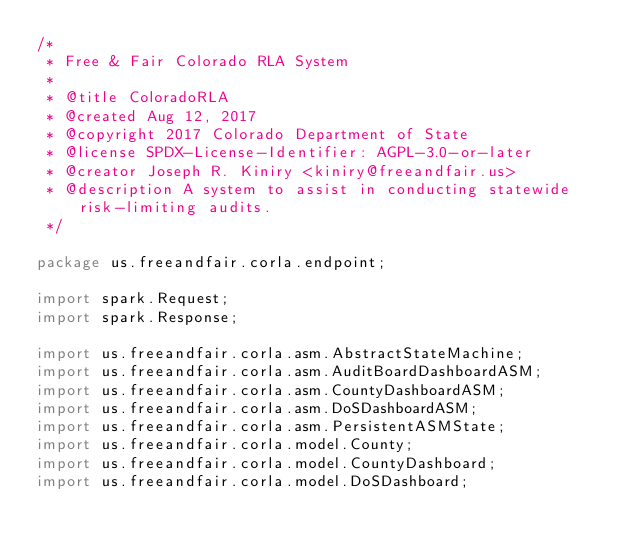<code> <loc_0><loc_0><loc_500><loc_500><_Java_>/*
 * Free & Fair Colorado RLA System
 * 
 * @title ColoradoRLA
 * @created Aug 12, 2017
 * @copyright 2017 Colorado Department of State
 * @license SPDX-License-Identifier: AGPL-3.0-or-later
 * @creator Joseph R. Kiniry <kiniry@freeandfair.us>
 * @description A system to assist in conducting statewide risk-limiting audits.
 */

package us.freeandfair.corla.endpoint;

import spark.Request;
import spark.Response;

import us.freeandfair.corla.asm.AbstractStateMachine;
import us.freeandfair.corla.asm.AuditBoardDashboardASM;
import us.freeandfair.corla.asm.CountyDashboardASM;
import us.freeandfair.corla.asm.DoSDashboardASM;
import us.freeandfair.corla.asm.PersistentASMState;
import us.freeandfair.corla.model.County;
import us.freeandfair.corla.model.CountyDashboard;
import us.freeandfair.corla.model.DoSDashboard;</code> 